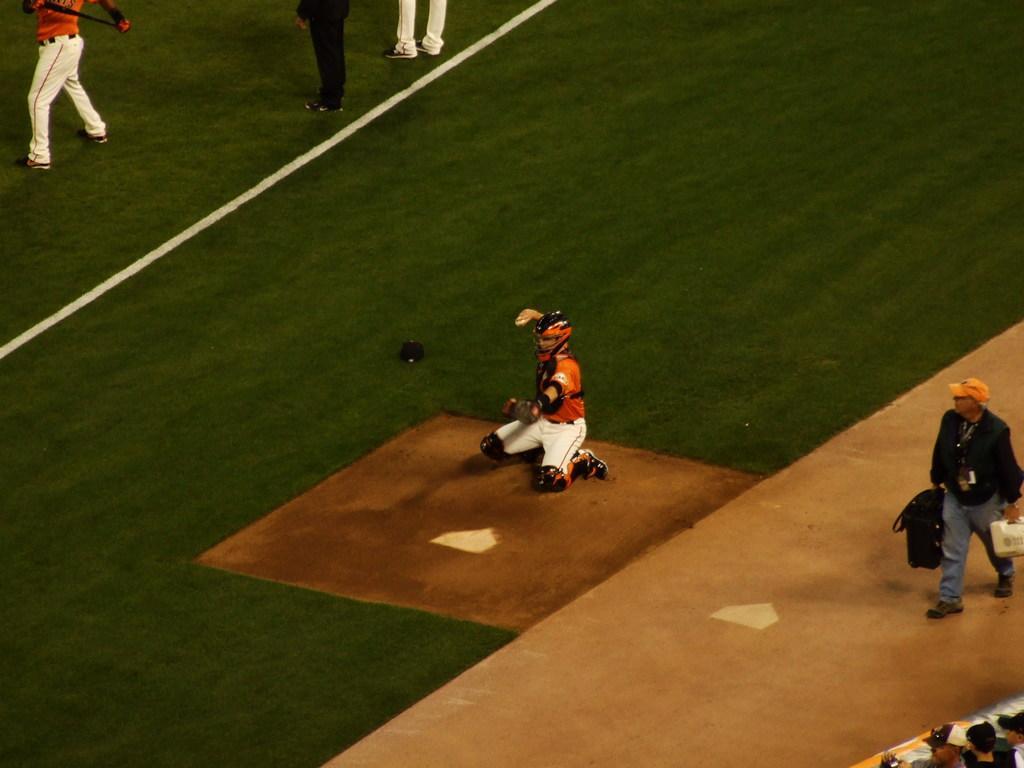Could you give a brief overview of what you see in this image? In the image I can see a person who is wearing the helmet and sitting on the ground and also I can see some other people. 